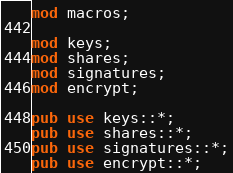Convert code to text. <code><loc_0><loc_0><loc_500><loc_500><_Rust_>mod macros;

mod keys;
mod shares;
mod signatures;
mod encrypt;

pub use keys::*;
pub use shares::*;
pub use signatures::*;
pub use encrypt::*;</code> 